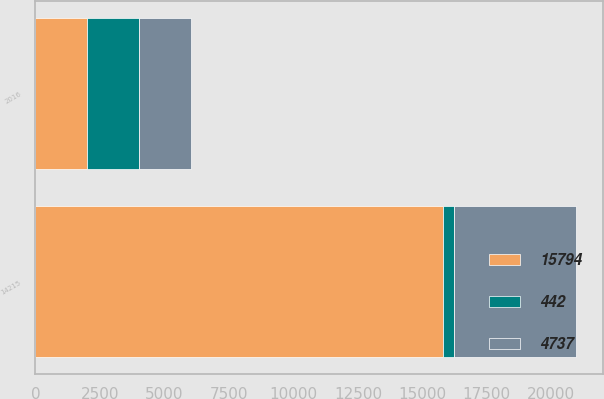<chart> <loc_0><loc_0><loc_500><loc_500><stacked_bar_chart><ecel><fcel>2016<fcel>14215<nl><fcel>15794<fcel>2015<fcel>15794<nl><fcel>442<fcel>2014<fcel>442<nl><fcel>4737<fcel>2013<fcel>4737<nl></chart> 